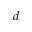<formula> <loc_0><loc_0><loc_500><loc_500>d</formula> 